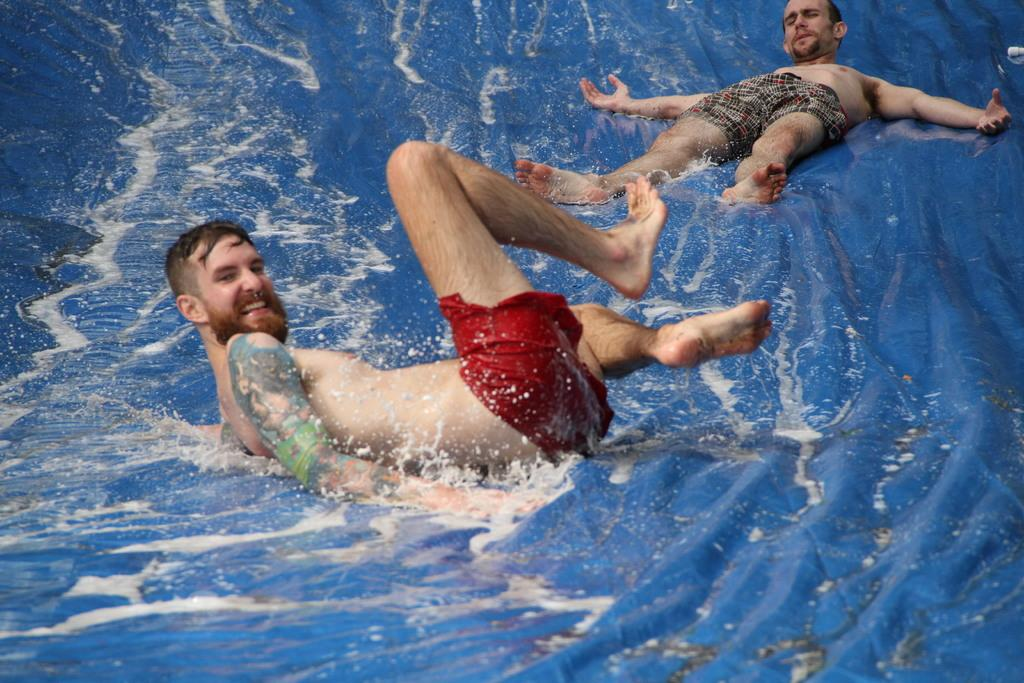What is the color of the surface in the image? The image has a blue surface. What is on the blue surface? There is water on the blue surface. How many people are in the image? There are two men in the image. What are the men wearing? The men are wearing shorts. What is the facial expression of one of the men? One of the men is smiling. Can you describe any distinguishing features of the men? There is a tattoo visible on one of the men. What type of attraction can be seen in the background of the image? There is no attraction visible in the background of the image. 